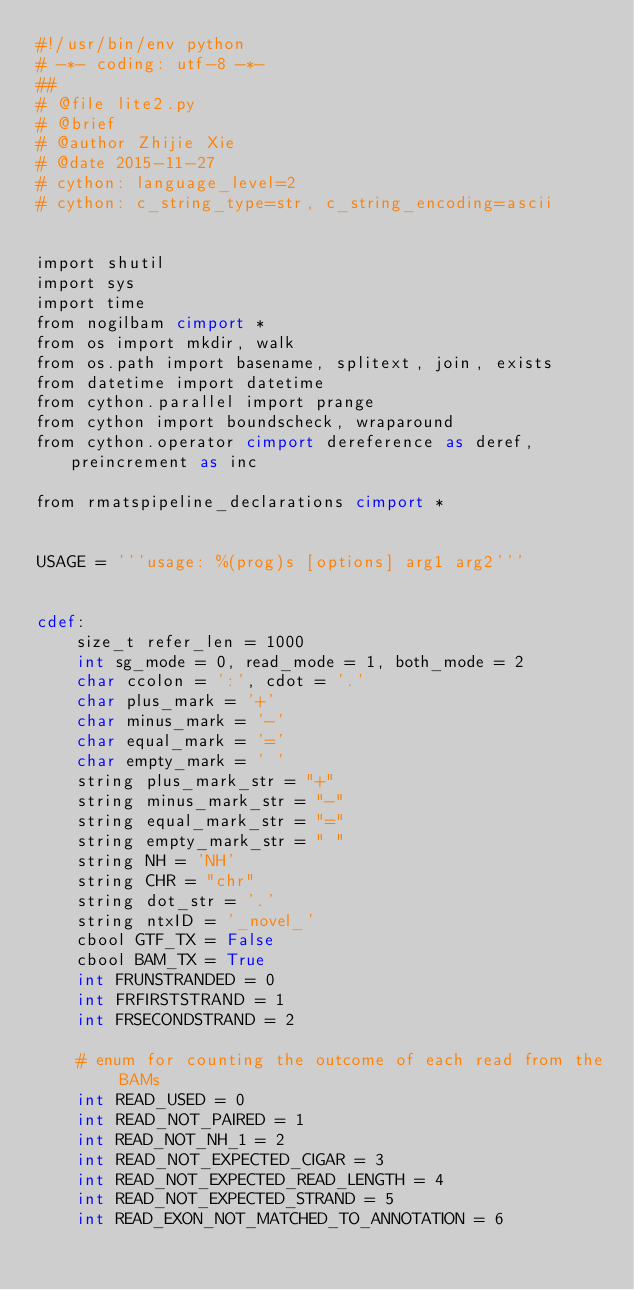Convert code to text. <code><loc_0><loc_0><loc_500><loc_500><_Cython_>#!/usr/bin/env python
# -*- coding: utf-8 -*-
##
# @file lite2.py
# @brief 
# @author Zhijie Xie
# @date 2015-11-27
# cython: language_level=2
# cython: c_string_type=str, c_string_encoding=ascii


import shutil
import sys
import time
from nogilbam cimport *
from os import mkdir, walk
from os.path import basename, splitext, join, exists
from datetime import datetime
from cython.parallel import prange
from cython import boundscheck, wraparound
from cython.operator cimport dereference as deref, preincrement as inc

from rmatspipeline_declarations cimport *


USAGE = '''usage: %(prog)s [options] arg1 arg2'''


cdef:
    size_t refer_len = 1000
    int sg_mode = 0, read_mode = 1, both_mode = 2
    char ccolon = ':', cdot = '.'
    char plus_mark = '+'
    char minus_mark = '-'
    char equal_mark = '='
    char empty_mark = ' '
    string plus_mark_str = "+"
    string minus_mark_str = "-"
    string equal_mark_str = "="
    string empty_mark_str = " "
    string NH = 'NH'
    string CHR = "chr"
    string dot_str = '.'
    string ntxID = '_novel_'
    cbool GTF_TX = False
    cbool BAM_TX = True
    int FRUNSTRANDED = 0
    int FRFIRSTSTRAND = 1
    int FRSECONDSTRAND = 2

    # enum for counting the outcome of each read from the BAMs
    int READ_USED = 0
    int READ_NOT_PAIRED = 1
    int READ_NOT_NH_1 = 2
    int READ_NOT_EXPECTED_CIGAR = 3
    int READ_NOT_EXPECTED_READ_LENGTH = 4
    int READ_NOT_EXPECTED_STRAND = 5
    int READ_EXON_NOT_MATCHED_TO_ANNOTATION = 6</code> 